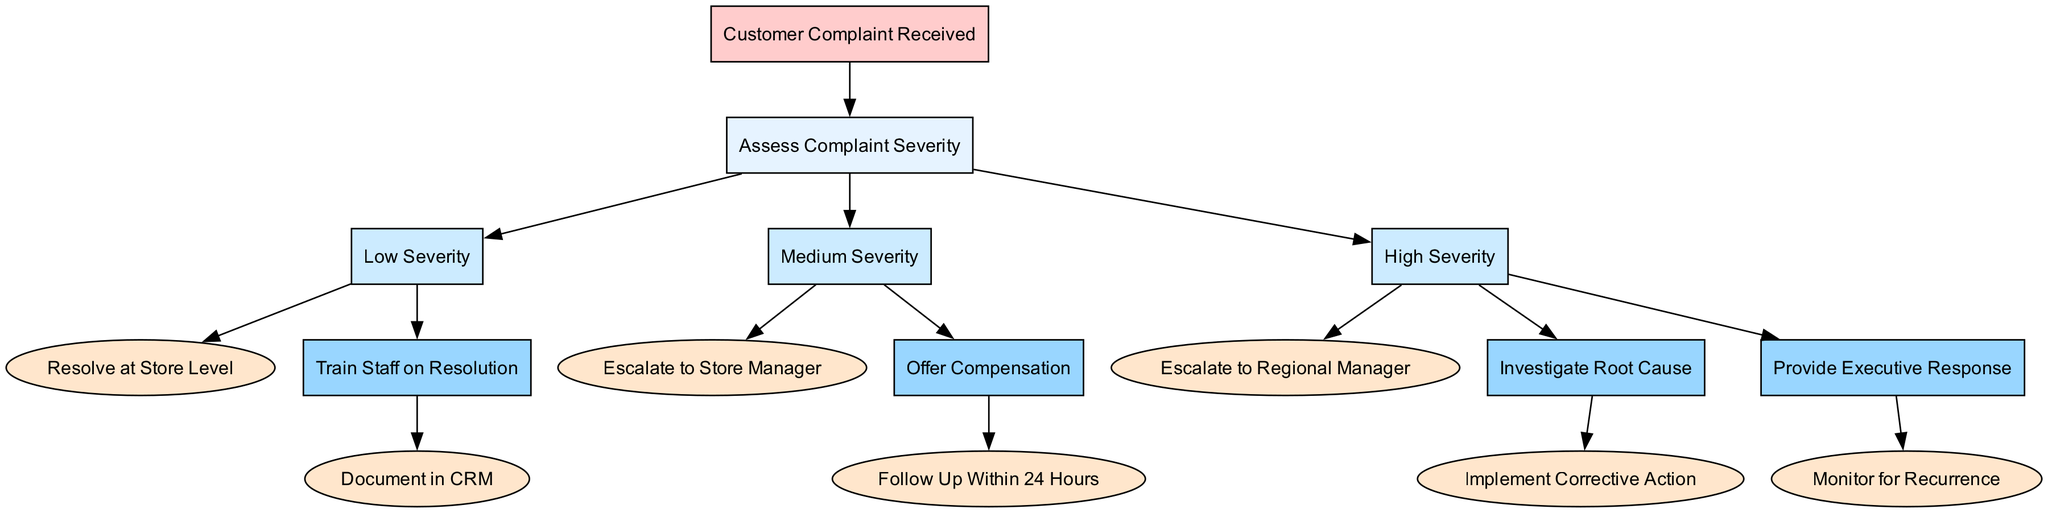What is the root node of the diagram? The root node of the diagram represents the starting point of the decision-making process, which is "Customer Complaint Received."
Answer: Customer Complaint Received How many different severities of complaints are assessed in the diagram? The diagram outlines three levels of complaint severity: Low Severity, Medium Severity, and High Severity, thus indicating three distinct categories of complaints.
Answer: 3 What action is taken for Low Severity complaints? For Low Severity complaints, the action specified is to "Resolve at Store Level," indicating that these complaints can be handled by the store's staff without further escalation.
Answer: Resolve at Store Level What is the follow-up action for Medium Severity complaints? The follow-up action specified for Medium Severity complaints is to "Follow Up Within 24 Hours," which indicates a commitment to timely communication after offering compensation.
Answer: Follow Up Within 24 Hours Which manager is involved in handling High Severity complaints? High Severity complaints are escalated to the "Regional Manager," indicating that these issues require higher-level intervention beyond the store manager's capacity.
Answer: Regional Manager What happens after investigating the root cause of High Severity complaints? After investigating the root cause of High Severity complaints, the action specified is to "Implement Corrective Action," meaning that measures will be taken to address the underlying issue.
Answer: Implement Corrective Action How many total nodes are present in the diagram if we count the actions? Including the actions associated with each severity level, we count the nodes: 1 root, 3 severity nodes, and their corresponding actions: 1 for Low, 1 for Medium, and 2 for High, totaling 8 nodes altogether.
Answer: 8 Where does the escalation for Medium Severity complaints take place? The escalation for Medium Severity complaints is directed towards the "Store Manager," indicating that this is the level to which these complaints are referred for further handling.
Answer: Store Manager 